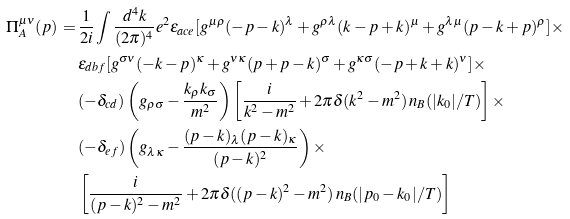<formula> <loc_0><loc_0><loc_500><loc_500>\Pi ^ { \mu \nu } _ { A } ( p ) \, = \, & \frac { 1 } { 2 i } \int \frac { d ^ { 4 } k } { ( 2 \pi ) ^ { 4 } } e ^ { 2 } \epsilon _ { a c e } [ g ^ { \mu \rho } ( - p - k ) ^ { \lambda } + g ^ { \rho \lambda } ( k - p + k ) ^ { \mu } + g ^ { \lambda \mu } ( p - k + p ) ^ { \rho } ] \times \\ & \epsilon _ { d b f } [ g ^ { \sigma \nu } ( - k - p ) ^ { \kappa } + g ^ { \nu \kappa } ( p + p - k ) ^ { \sigma } + g ^ { \kappa \sigma } ( - p + k + k ) ^ { \nu } ] \times \\ & ( - \delta _ { c d } ) \left ( g _ { \rho \sigma } - \frac { k _ { \rho } k _ { \sigma } } { m ^ { 2 } } \right ) \left [ \frac { i } { k ^ { 2 } - m ^ { 2 } } + 2 \pi \delta ( k ^ { 2 } - m ^ { 2 } ) \, n _ { B } ( | k _ { 0 } | / T ) \right ] \times \\ & ( - \delta _ { e f } ) \left ( g _ { \lambda \kappa } - \frac { ( p - k ) _ { \lambda } ( p - k ) _ { \kappa } } { ( p - k ) ^ { 2 } } \right ) \times \\ & \left [ \frac { i } { ( p - k ) ^ { 2 } - m ^ { 2 } } + 2 \pi \delta ( ( p - k ) ^ { 2 } - m ^ { 2 } ) \, n _ { B } ( | p _ { 0 } - k _ { 0 } | / T ) \right ]</formula> 